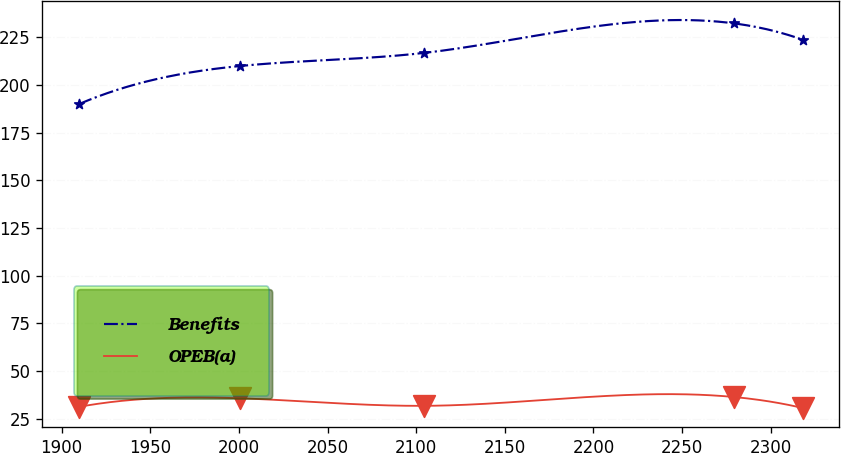Convert chart to OTSL. <chart><loc_0><loc_0><loc_500><loc_500><line_chart><ecel><fcel>Benefits<fcel>OPEB(a)<nl><fcel>1909.64<fcel>189.83<fcel>31.1<nl><fcel>2000.68<fcel>209.88<fcel>35.64<nl><fcel>2104.66<fcel>216.77<fcel>31.68<nl><fcel>2279.05<fcel>232.26<fcel>36.32<nl><fcel>2318.1<fcel>223.63<fcel>30.52<nl></chart> 